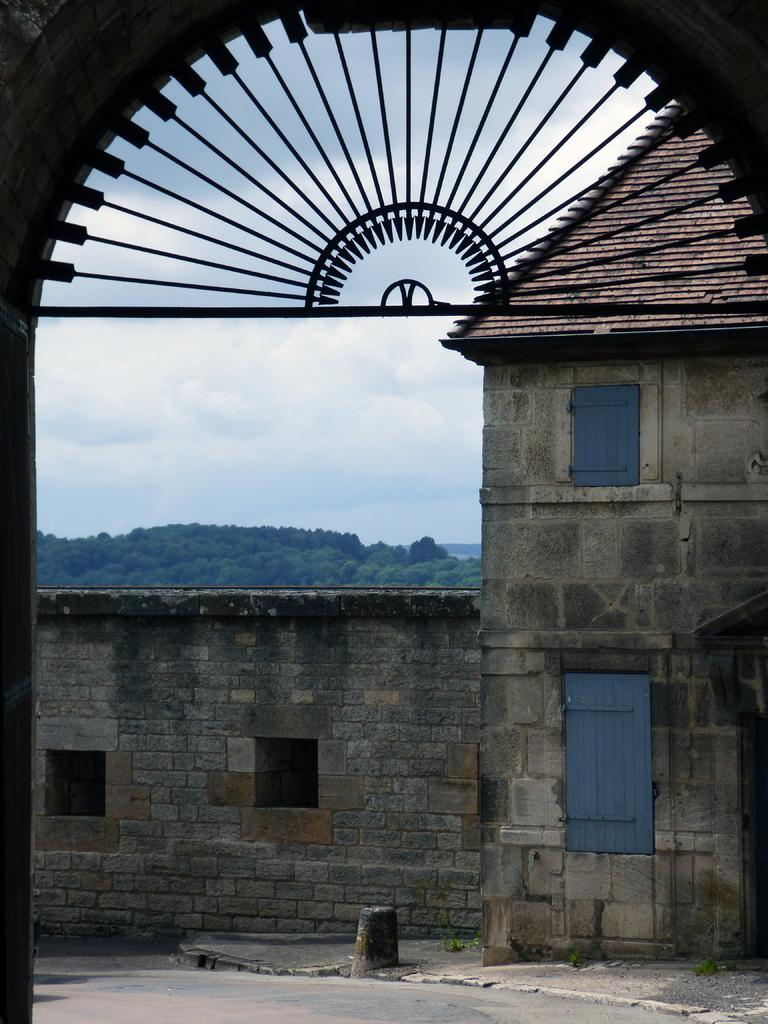What material is the building made of? The building is made up of rocks. Are there any openings in the building? Yes, there are windows in the building. What is covering the top of the building? The roof of the building is visible. What type of barrier is present in the image? There is a metal railing in the image. What can be seen in the background of the image? There are trees and the sky visible in the background of the image. What type of berry is growing on the roof of the building in the image? There are no berries present on the roof of the building in the image. 